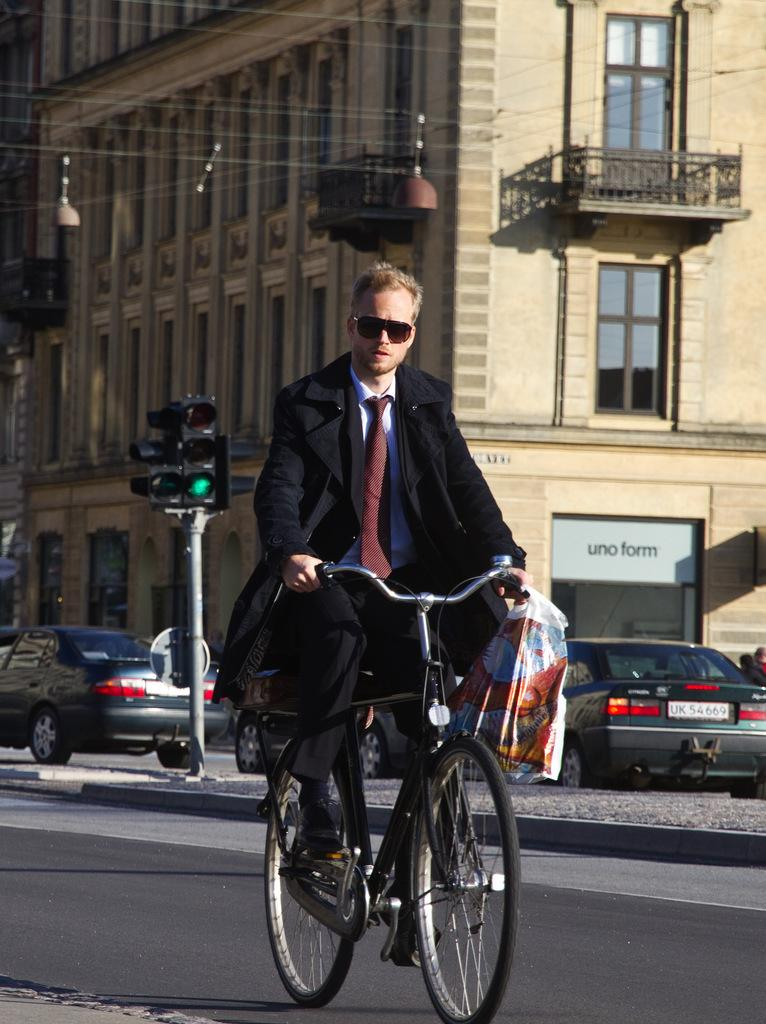What is the man in the image doing? The man is riding a bicycle in the image. What is the man holding while riding the bicycle? The man is holding a bag in his hand. What can be seen in the background of the image? There are vehicles, a traffic signal pole, and a building visible in the background. What type of liquid is the man spilling from his pocket in the image? There is no liquid or pocket visible in the image; the man is holding a bag in his hand while riding a bicycle. 